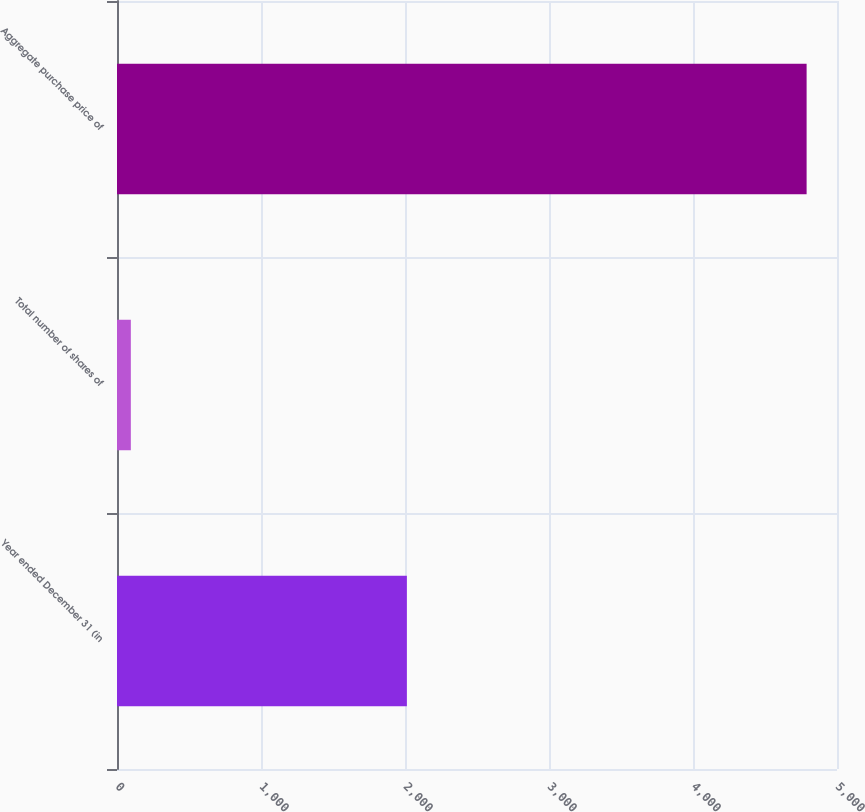Convert chart to OTSL. <chart><loc_0><loc_0><loc_500><loc_500><bar_chart><fcel>Year ended December 31 (in<fcel>Total number of shares of<fcel>Aggregate purchase price of<nl><fcel>2013<fcel>96.1<fcel>4789<nl></chart> 